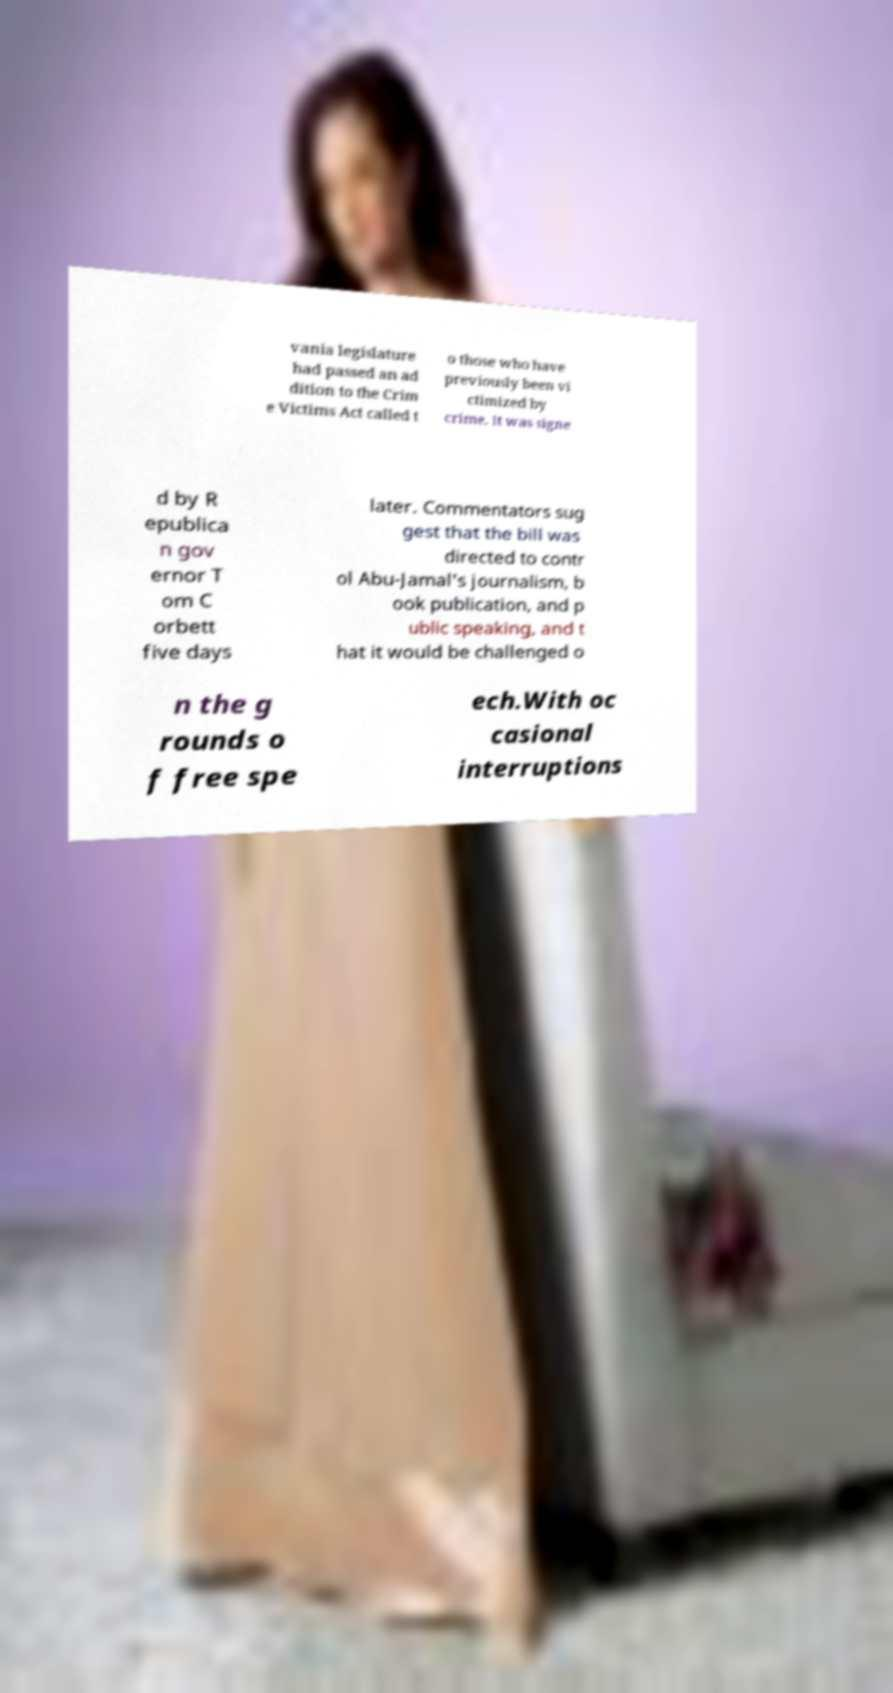For documentation purposes, I need the text within this image transcribed. Could you provide that? vania legislature had passed an ad dition to the Crim e Victims Act called t o those who have previously been vi ctimized by crime. It was signe d by R epublica n gov ernor T om C orbett five days later. Commentators sug gest that the bill was directed to contr ol Abu-Jamal's journalism, b ook publication, and p ublic speaking, and t hat it would be challenged o n the g rounds o f free spe ech.With oc casional interruptions 